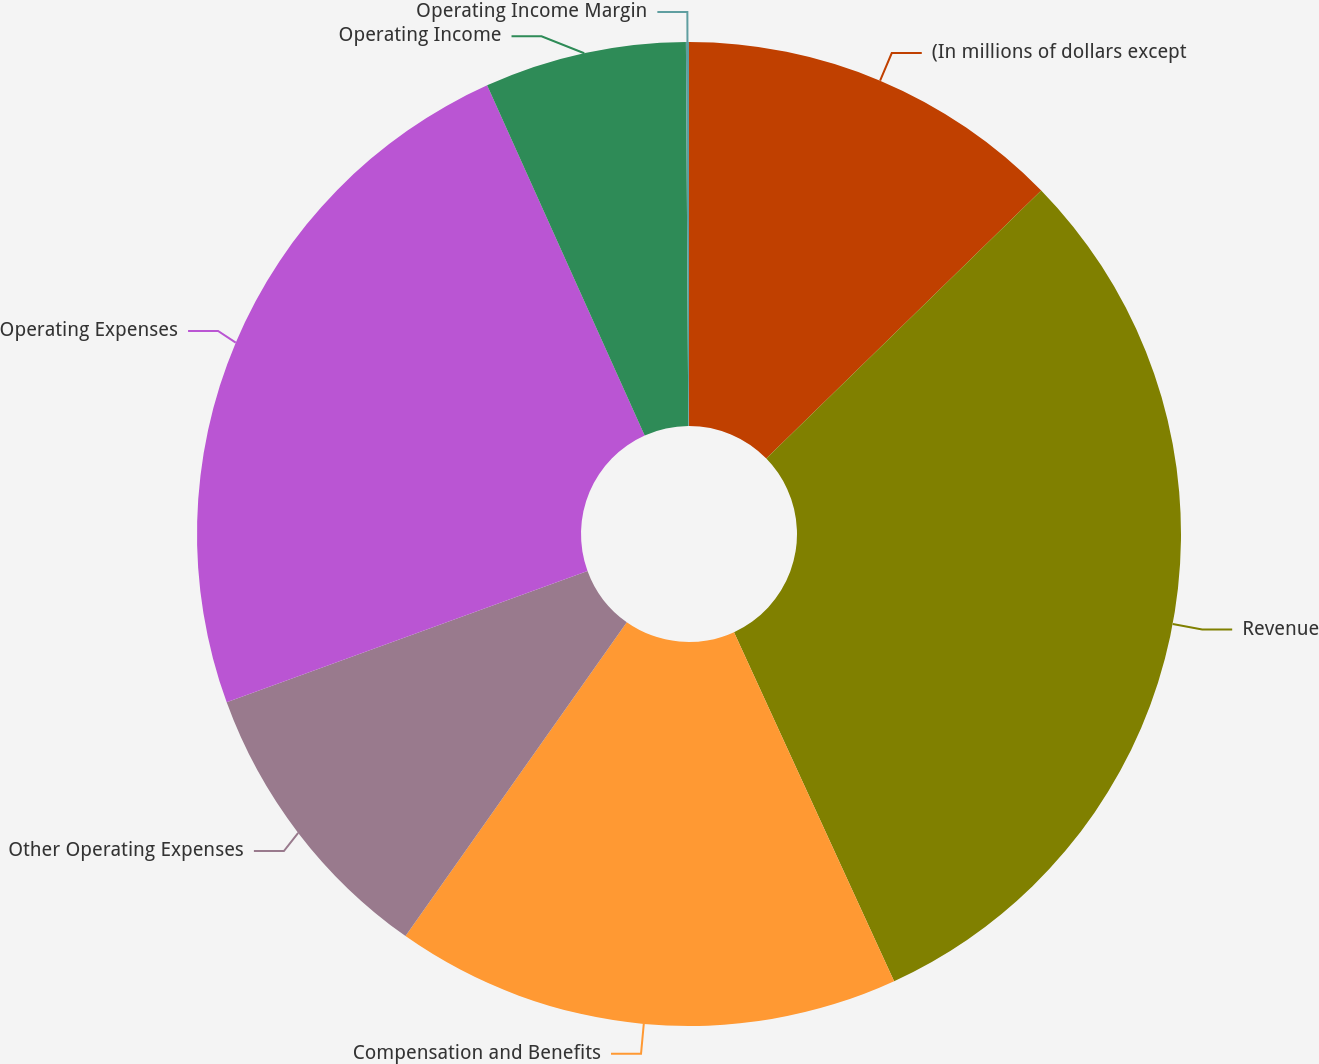Convert chart to OTSL. <chart><loc_0><loc_0><loc_500><loc_500><pie_chart><fcel>(In millions of dollars except<fcel>Revenue<fcel>Compensation and Benefits<fcel>Other Operating Expenses<fcel>Operating Expenses<fcel>Operating Income<fcel>Operating Income Margin<nl><fcel>12.7%<fcel>30.46%<fcel>16.62%<fcel>9.67%<fcel>23.83%<fcel>6.63%<fcel>0.1%<nl></chart> 